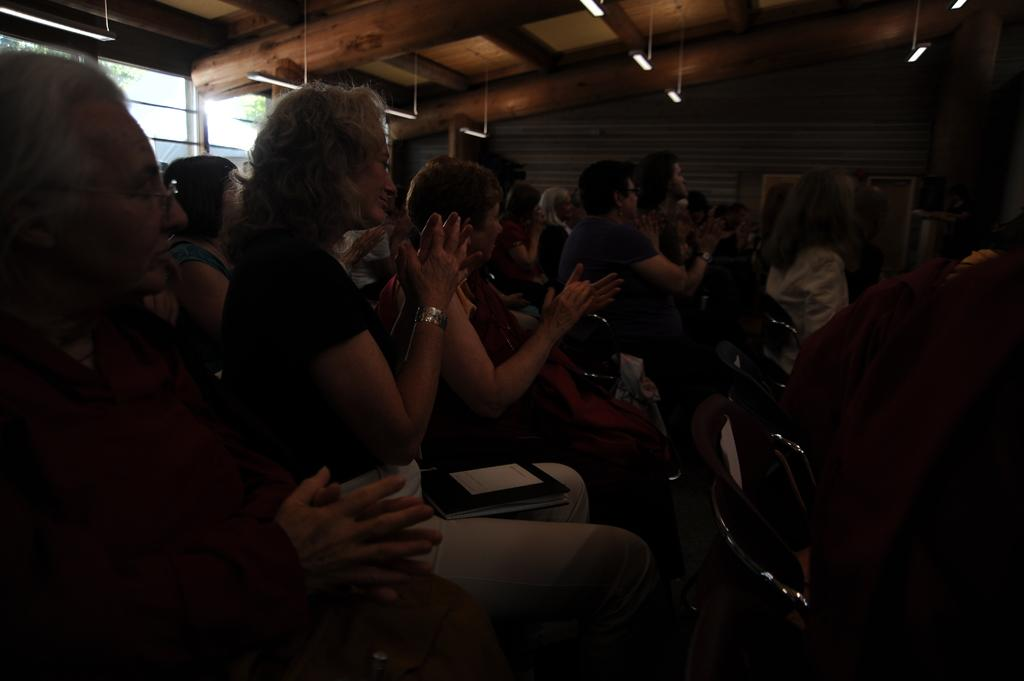What are the women doing in the image? The women are sitting on chairs on the left side of the image and clapping their hands. Where are the lights located in the image? The lights are visible at the top of the image. What type of vessel is being used by the women to express their feelings in the image? There is no vessel present in the image, and the women are expressing their feelings by clapping their hands. 